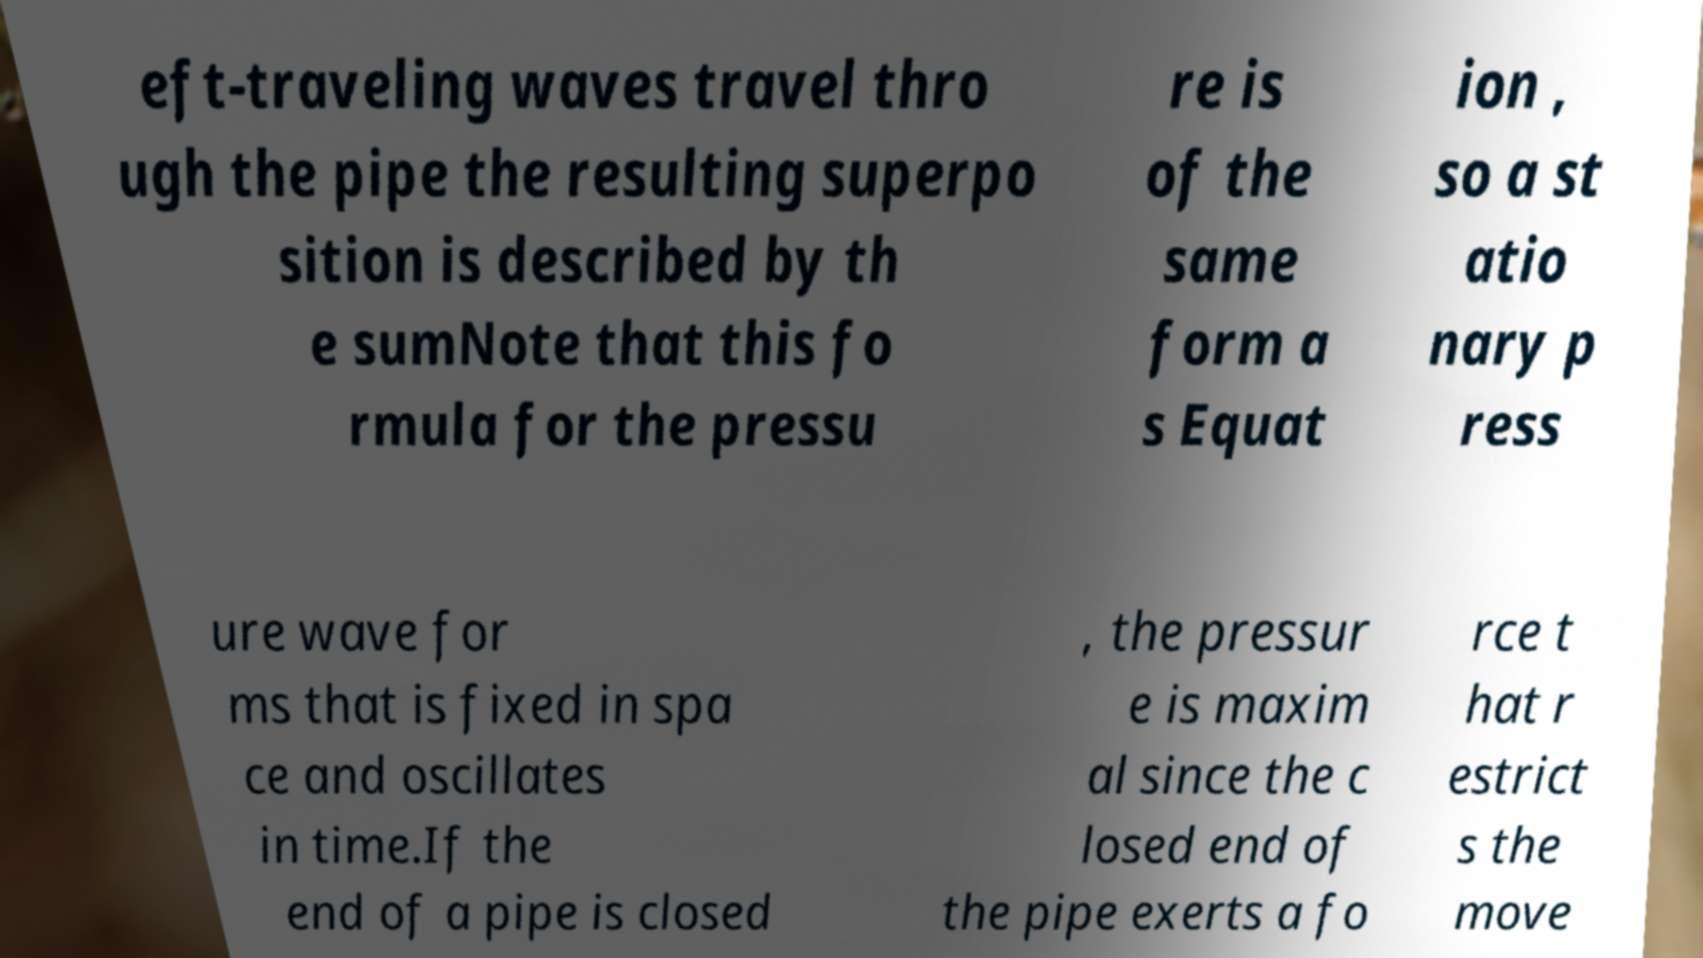Please identify and transcribe the text found in this image. eft-traveling waves travel thro ugh the pipe the resulting superpo sition is described by th e sumNote that this fo rmula for the pressu re is of the same form a s Equat ion , so a st atio nary p ress ure wave for ms that is fixed in spa ce and oscillates in time.If the end of a pipe is closed , the pressur e is maxim al since the c losed end of the pipe exerts a fo rce t hat r estrict s the move 